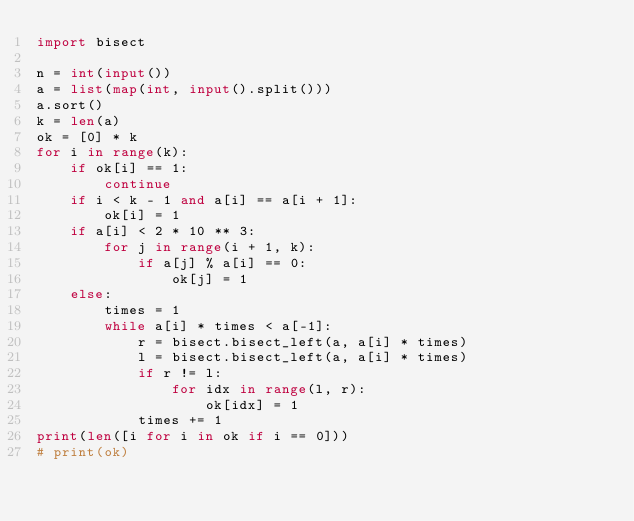Convert code to text. <code><loc_0><loc_0><loc_500><loc_500><_Python_>import bisect

n = int(input())
a = list(map(int, input().split()))
a.sort()
k = len(a)
ok = [0] * k
for i in range(k):
    if ok[i] == 1:
        continue
    if i < k - 1 and a[i] == a[i + 1]:
        ok[i] = 1
    if a[i] < 2 * 10 ** 3:
        for j in range(i + 1, k):
            if a[j] % a[i] == 0:
                ok[j] = 1
    else:
        times = 1
        while a[i] * times < a[-1]:
            r = bisect.bisect_left(a, a[i] * times)
            l = bisect.bisect_left(a, a[i] * times)
            if r != l:
                for idx in range(l, r):
                    ok[idx] = 1
            times += 1
print(len([i for i in ok if i == 0]))
# print(ok)
</code> 